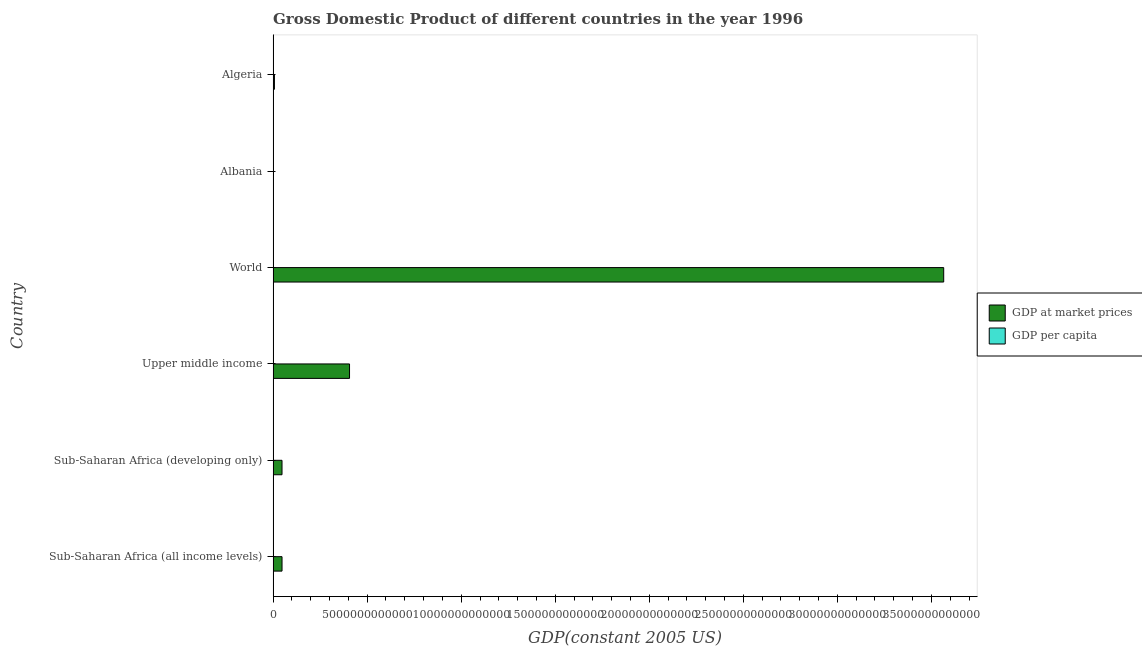Are the number of bars on each tick of the Y-axis equal?
Your answer should be compact. Yes. How many bars are there on the 3rd tick from the bottom?
Ensure brevity in your answer.  2. What is the label of the 1st group of bars from the top?
Give a very brief answer. Algeria. What is the gdp per capita in Sub-Saharan Africa (developing only)?
Offer a very short reply. 789. Across all countries, what is the maximum gdp at market prices?
Offer a terse response. 3.57e+13. Across all countries, what is the minimum gdp at market prices?
Offer a very short reply. 5.21e+09. In which country was the gdp per capita maximum?
Your answer should be very brief. World. In which country was the gdp per capita minimum?
Make the answer very short. Sub-Saharan Africa (developing only). What is the total gdp at market prices in the graph?
Make the answer very short. 4.07e+13. What is the difference between the gdp at market prices in Upper middle income and that in World?
Your answer should be very brief. -3.16e+13. What is the difference between the gdp per capita in Sub-Saharan Africa (all income levels) and the gdp at market prices in Upper middle income?
Make the answer very short. -4.06e+12. What is the average gdp at market prices per country?
Provide a short and direct response. 6.79e+12. What is the difference between the gdp per capita and gdp at market prices in Albania?
Provide a short and direct response. -5.21e+09. What is the ratio of the gdp per capita in Albania to that in Sub-Saharan Africa (developing only)?
Make the answer very short. 2.09. Is the gdp per capita in Algeria less than that in Sub-Saharan Africa (developing only)?
Ensure brevity in your answer.  No. What is the difference between the highest and the second highest gdp at market prices?
Ensure brevity in your answer.  3.16e+13. What is the difference between the highest and the lowest gdp at market prices?
Provide a short and direct response. 3.56e+13. In how many countries, is the gdp at market prices greater than the average gdp at market prices taken over all countries?
Give a very brief answer. 1. What does the 1st bar from the top in World represents?
Give a very brief answer. GDP per capita. What does the 2nd bar from the bottom in Sub-Saharan Africa (all income levels) represents?
Make the answer very short. GDP per capita. How many countries are there in the graph?
Make the answer very short. 6. What is the difference between two consecutive major ticks on the X-axis?
Offer a very short reply. 5.00e+12. Are the values on the major ticks of X-axis written in scientific E-notation?
Provide a short and direct response. No. Does the graph contain any zero values?
Ensure brevity in your answer.  No. Where does the legend appear in the graph?
Offer a very short reply. Center right. How are the legend labels stacked?
Provide a succinct answer. Vertical. What is the title of the graph?
Keep it short and to the point. Gross Domestic Product of different countries in the year 1996. Does "Girls" appear as one of the legend labels in the graph?
Your answer should be compact. No. What is the label or title of the X-axis?
Give a very brief answer. GDP(constant 2005 US). What is the GDP(constant 2005 US) in GDP at market prices in Sub-Saharan Africa (all income levels)?
Keep it short and to the point. 4.74e+11. What is the GDP(constant 2005 US) of GDP per capita in Sub-Saharan Africa (all income levels)?
Your response must be concise. 789.86. What is the GDP(constant 2005 US) in GDP at market prices in Sub-Saharan Africa (developing only)?
Your response must be concise. 4.73e+11. What is the GDP(constant 2005 US) in GDP per capita in Sub-Saharan Africa (developing only)?
Provide a succinct answer. 789. What is the GDP(constant 2005 US) of GDP at market prices in Upper middle income?
Your answer should be very brief. 4.06e+12. What is the GDP(constant 2005 US) in GDP per capita in Upper middle income?
Keep it short and to the point. 2022.09. What is the GDP(constant 2005 US) in GDP at market prices in World?
Give a very brief answer. 3.57e+13. What is the GDP(constant 2005 US) of GDP per capita in World?
Your answer should be very brief. 6159.46. What is the GDP(constant 2005 US) of GDP at market prices in Albania?
Your answer should be very brief. 5.21e+09. What is the GDP(constant 2005 US) of GDP per capita in Albania?
Ensure brevity in your answer.  1645.58. What is the GDP(constant 2005 US) in GDP at market prices in Algeria?
Offer a very short reply. 7.04e+1. What is the GDP(constant 2005 US) in GDP per capita in Algeria?
Your response must be concise. 2393.55. Across all countries, what is the maximum GDP(constant 2005 US) of GDP at market prices?
Make the answer very short. 3.57e+13. Across all countries, what is the maximum GDP(constant 2005 US) in GDP per capita?
Provide a short and direct response. 6159.46. Across all countries, what is the minimum GDP(constant 2005 US) of GDP at market prices?
Keep it short and to the point. 5.21e+09. Across all countries, what is the minimum GDP(constant 2005 US) of GDP per capita?
Your response must be concise. 789. What is the total GDP(constant 2005 US) in GDP at market prices in the graph?
Offer a very short reply. 4.07e+13. What is the total GDP(constant 2005 US) of GDP per capita in the graph?
Ensure brevity in your answer.  1.38e+04. What is the difference between the GDP(constant 2005 US) of GDP at market prices in Sub-Saharan Africa (all income levels) and that in Sub-Saharan Africa (developing only)?
Provide a succinct answer. 9.37e+08. What is the difference between the GDP(constant 2005 US) of GDP per capita in Sub-Saharan Africa (all income levels) and that in Sub-Saharan Africa (developing only)?
Provide a succinct answer. 0.85. What is the difference between the GDP(constant 2005 US) in GDP at market prices in Sub-Saharan Africa (all income levels) and that in Upper middle income?
Keep it short and to the point. -3.59e+12. What is the difference between the GDP(constant 2005 US) of GDP per capita in Sub-Saharan Africa (all income levels) and that in Upper middle income?
Offer a terse response. -1232.23. What is the difference between the GDP(constant 2005 US) of GDP at market prices in Sub-Saharan Africa (all income levels) and that in World?
Offer a terse response. -3.52e+13. What is the difference between the GDP(constant 2005 US) of GDP per capita in Sub-Saharan Africa (all income levels) and that in World?
Offer a very short reply. -5369.61. What is the difference between the GDP(constant 2005 US) in GDP at market prices in Sub-Saharan Africa (all income levels) and that in Albania?
Keep it short and to the point. 4.69e+11. What is the difference between the GDP(constant 2005 US) of GDP per capita in Sub-Saharan Africa (all income levels) and that in Albania?
Offer a very short reply. -855.72. What is the difference between the GDP(constant 2005 US) in GDP at market prices in Sub-Saharan Africa (all income levels) and that in Algeria?
Ensure brevity in your answer.  4.03e+11. What is the difference between the GDP(constant 2005 US) in GDP per capita in Sub-Saharan Africa (all income levels) and that in Algeria?
Offer a terse response. -1603.7. What is the difference between the GDP(constant 2005 US) of GDP at market prices in Sub-Saharan Africa (developing only) and that in Upper middle income?
Ensure brevity in your answer.  -3.59e+12. What is the difference between the GDP(constant 2005 US) in GDP per capita in Sub-Saharan Africa (developing only) and that in Upper middle income?
Provide a succinct answer. -1233.09. What is the difference between the GDP(constant 2005 US) of GDP at market prices in Sub-Saharan Africa (developing only) and that in World?
Offer a very short reply. -3.52e+13. What is the difference between the GDP(constant 2005 US) of GDP per capita in Sub-Saharan Africa (developing only) and that in World?
Provide a short and direct response. -5370.46. What is the difference between the GDP(constant 2005 US) in GDP at market prices in Sub-Saharan Africa (developing only) and that in Albania?
Keep it short and to the point. 4.68e+11. What is the difference between the GDP(constant 2005 US) in GDP per capita in Sub-Saharan Africa (developing only) and that in Albania?
Your response must be concise. -856.57. What is the difference between the GDP(constant 2005 US) of GDP at market prices in Sub-Saharan Africa (developing only) and that in Algeria?
Provide a succinct answer. 4.02e+11. What is the difference between the GDP(constant 2005 US) of GDP per capita in Sub-Saharan Africa (developing only) and that in Algeria?
Your answer should be very brief. -1604.55. What is the difference between the GDP(constant 2005 US) in GDP at market prices in Upper middle income and that in World?
Your answer should be very brief. -3.16e+13. What is the difference between the GDP(constant 2005 US) in GDP per capita in Upper middle income and that in World?
Your answer should be compact. -4137.37. What is the difference between the GDP(constant 2005 US) of GDP at market prices in Upper middle income and that in Albania?
Provide a succinct answer. 4.06e+12. What is the difference between the GDP(constant 2005 US) of GDP per capita in Upper middle income and that in Albania?
Your response must be concise. 376.51. What is the difference between the GDP(constant 2005 US) in GDP at market prices in Upper middle income and that in Algeria?
Give a very brief answer. 3.99e+12. What is the difference between the GDP(constant 2005 US) in GDP per capita in Upper middle income and that in Algeria?
Provide a succinct answer. -371.46. What is the difference between the GDP(constant 2005 US) of GDP at market prices in World and that in Albania?
Give a very brief answer. 3.56e+13. What is the difference between the GDP(constant 2005 US) of GDP per capita in World and that in Albania?
Ensure brevity in your answer.  4513.88. What is the difference between the GDP(constant 2005 US) in GDP at market prices in World and that in Algeria?
Your answer should be very brief. 3.56e+13. What is the difference between the GDP(constant 2005 US) of GDP per capita in World and that in Algeria?
Your answer should be compact. 3765.91. What is the difference between the GDP(constant 2005 US) of GDP at market prices in Albania and that in Algeria?
Offer a terse response. -6.52e+1. What is the difference between the GDP(constant 2005 US) of GDP per capita in Albania and that in Algeria?
Offer a very short reply. -747.98. What is the difference between the GDP(constant 2005 US) in GDP at market prices in Sub-Saharan Africa (all income levels) and the GDP(constant 2005 US) in GDP per capita in Sub-Saharan Africa (developing only)?
Your answer should be compact. 4.74e+11. What is the difference between the GDP(constant 2005 US) in GDP at market prices in Sub-Saharan Africa (all income levels) and the GDP(constant 2005 US) in GDP per capita in Upper middle income?
Make the answer very short. 4.74e+11. What is the difference between the GDP(constant 2005 US) of GDP at market prices in Sub-Saharan Africa (all income levels) and the GDP(constant 2005 US) of GDP per capita in World?
Provide a short and direct response. 4.74e+11. What is the difference between the GDP(constant 2005 US) in GDP at market prices in Sub-Saharan Africa (all income levels) and the GDP(constant 2005 US) in GDP per capita in Albania?
Offer a very short reply. 4.74e+11. What is the difference between the GDP(constant 2005 US) in GDP at market prices in Sub-Saharan Africa (all income levels) and the GDP(constant 2005 US) in GDP per capita in Algeria?
Provide a short and direct response. 4.74e+11. What is the difference between the GDP(constant 2005 US) of GDP at market prices in Sub-Saharan Africa (developing only) and the GDP(constant 2005 US) of GDP per capita in Upper middle income?
Offer a very short reply. 4.73e+11. What is the difference between the GDP(constant 2005 US) of GDP at market prices in Sub-Saharan Africa (developing only) and the GDP(constant 2005 US) of GDP per capita in World?
Your answer should be very brief. 4.73e+11. What is the difference between the GDP(constant 2005 US) of GDP at market prices in Sub-Saharan Africa (developing only) and the GDP(constant 2005 US) of GDP per capita in Albania?
Ensure brevity in your answer.  4.73e+11. What is the difference between the GDP(constant 2005 US) in GDP at market prices in Sub-Saharan Africa (developing only) and the GDP(constant 2005 US) in GDP per capita in Algeria?
Ensure brevity in your answer.  4.73e+11. What is the difference between the GDP(constant 2005 US) in GDP at market prices in Upper middle income and the GDP(constant 2005 US) in GDP per capita in World?
Ensure brevity in your answer.  4.06e+12. What is the difference between the GDP(constant 2005 US) in GDP at market prices in Upper middle income and the GDP(constant 2005 US) in GDP per capita in Albania?
Provide a short and direct response. 4.06e+12. What is the difference between the GDP(constant 2005 US) of GDP at market prices in Upper middle income and the GDP(constant 2005 US) of GDP per capita in Algeria?
Offer a terse response. 4.06e+12. What is the difference between the GDP(constant 2005 US) of GDP at market prices in World and the GDP(constant 2005 US) of GDP per capita in Albania?
Your answer should be very brief. 3.57e+13. What is the difference between the GDP(constant 2005 US) in GDP at market prices in World and the GDP(constant 2005 US) in GDP per capita in Algeria?
Provide a short and direct response. 3.57e+13. What is the difference between the GDP(constant 2005 US) in GDP at market prices in Albania and the GDP(constant 2005 US) in GDP per capita in Algeria?
Your answer should be compact. 5.21e+09. What is the average GDP(constant 2005 US) in GDP at market prices per country?
Provide a succinct answer. 6.79e+12. What is the average GDP(constant 2005 US) in GDP per capita per country?
Offer a terse response. 2299.92. What is the difference between the GDP(constant 2005 US) in GDP at market prices and GDP(constant 2005 US) in GDP per capita in Sub-Saharan Africa (all income levels)?
Provide a short and direct response. 4.74e+11. What is the difference between the GDP(constant 2005 US) in GDP at market prices and GDP(constant 2005 US) in GDP per capita in Sub-Saharan Africa (developing only)?
Your answer should be compact. 4.73e+11. What is the difference between the GDP(constant 2005 US) of GDP at market prices and GDP(constant 2005 US) of GDP per capita in Upper middle income?
Your response must be concise. 4.06e+12. What is the difference between the GDP(constant 2005 US) in GDP at market prices and GDP(constant 2005 US) in GDP per capita in World?
Keep it short and to the point. 3.57e+13. What is the difference between the GDP(constant 2005 US) in GDP at market prices and GDP(constant 2005 US) in GDP per capita in Albania?
Offer a terse response. 5.21e+09. What is the difference between the GDP(constant 2005 US) in GDP at market prices and GDP(constant 2005 US) in GDP per capita in Algeria?
Ensure brevity in your answer.  7.04e+1. What is the ratio of the GDP(constant 2005 US) in GDP at market prices in Sub-Saharan Africa (all income levels) to that in Upper middle income?
Your response must be concise. 0.12. What is the ratio of the GDP(constant 2005 US) of GDP per capita in Sub-Saharan Africa (all income levels) to that in Upper middle income?
Keep it short and to the point. 0.39. What is the ratio of the GDP(constant 2005 US) in GDP at market prices in Sub-Saharan Africa (all income levels) to that in World?
Make the answer very short. 0.01. What is the ratio of the GDP(constant 2005 US) in GDP per capita in Sub-Saharan Africa (all income levels) to that in World?
Offer a terse response. 0.13. What is the ratio of the GDP(constant 2005 US) in GDP at market prices in Sub-Saharan Africa (all income levels) to that in Albania?
Give a very brief answer. 90.88. What is the ratio of the GDP(constant 2005 US) in GDP per capita in Sub-Saharan Africa (all income levels) to that in Albania?
Ensure brevity in your answer.  0.48. What is the ratio of the GDP(constant 2005 US) in GDP at market prices in Sub-Saharan Africa (all income levels) to that in Algeria?
Give a very brief answer. 6.73. What is the ratio of the GDP(constant 2005 US) of GDP per capita in Sub-Saharan Africa (all income levels) to that in Algeria?
Offer a terse response. 0.33. What is the ratio of the GDP(constant 2005 US) of GDP at market prices in Sub-Saharan Africa (developing only) to that in Upper middle income?
Your answer should be very brief. 0.12. What is the ratio of the GDP(constant 2005 US) of GDP per capita in Sub-Saharan Africa (developing only) to that in Upper middle income?
Offer a terse response. 0.39. What is the ratio of the GDP(constant 2005 US) of GDP at market prices in Sub-Saharan Africa (developing only) to that in World?
Offer a very short reply. 0.01. What is the ratio of the GDP(constant 2005 US) in GDP per capita in Sub-Saharan Africa (developing only) to that in World?
Provide a succinct answer. 0.13. What is the ratio of the GDP(constant 2005 US) in GDP at market prices in Sub-Saharan Africa (developing only) to that in Albania?
Make the answer very short. 90.7. What is the ratio of the GDP(constant 2005 US) of GDP per capita in Sub-Saharan Africa (developing only) to that in Albania?
Provide a succinct answer. 0.48. What is the ratio of the GDP(constant 2005 US) of GDP at market prices in Sub-Saharan Africa (developing only) to that in Algeria?
Offer a terse response. 6.72. What is the ratio of the GDP(constant 2005 US) in GDP per capita in Sub-Saharan Africa (developing only) to that in Algeria?
Provide a succinct answer. 0.33. What is the ratio of the GDP(constant 2005 US) of GDP at market prices in Upper middle income to that in World?
Give a very brief answer. 0.11. What is the ratio of the GDP(constant 2005 US) in GDP per capita in Upper middle income to that in World?
Your response must be concise. 0.33. What is the ratio of the GDP(constant 2005 US) in GDP at market prices in Upper middle income to that in Albania?
Your answer should be very brief. 779.31. What is the ratio of the GDP(constant 2005 US) of GDP per capita in Upper middle income to that in Albania?
Make the answer very short. 1.23. What is the ratio of the GDP(constant 2005 US) in GDP at market prices in Upper middle income to that in Algeria?
Give a very brief answer. 57.71. What is the ratio of the GDP(constant 2005 US) in GDP per capita in Upper middle income to that in Algeria?
Your answer should be very brief. 0.84. What is the ratio of the GDP(constant 2005 US) of GDP at market prices in World to that in Albania?
Keep it short and to the point. 6839.29. What is the ratio of the GDP(constant 2005 US) in GDP per capita in World to that in Albania?
Ensure brevity in your answer.  3.74. What is the ratio of the GDP(constant 2005 US) of GDP at market prices in World to that in Algeria?
Your response must be concise. 506.47. What is the ratio of the GDP(constant 2005 US) in GDP per capita in World to that in Algeria?
Offer a very short reply. 2.57. What is the ratio of the GDP(constant 2005 US) of GDP at market prices in Albania to that in Algeria?
Your response must be concise. 0.07. What is the ratio of the GDP(constant 2005 US) of GDP per capita in Albania to that in Algeria?
Your answer should be compact. 0.69. What is the difference between the highest and the second highest GDP(constant 2005 US) of GDP at market prices?
Offer a very short reply. 3.16e+13. What is the difference between the highest and the second highest GDP(constant 2005 US) of GDP per capita?
Offer a very short reply. 3765.91. What is the difference between the highest and the lowest GDP(constant 2005 US) in GDP at market prices?
Your response must be concise. 3.56e+13. What is the difference between the highest and the lowest GDP(constant 2005 US) of GDP per capita?
Offer a very short reply. 5370.46. 